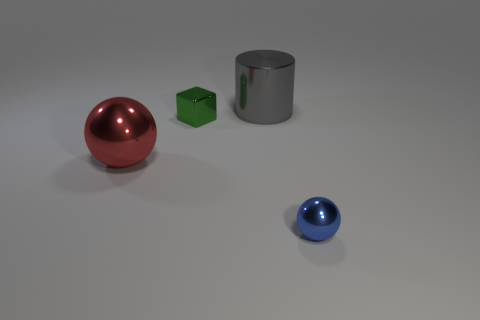There is a thing that is in front of the sphere on the left side of the tiny metal sphere; is there a large metal sphere left of it?
Offer a terse response. Yes. What shape is the small green thing that is the same material as the cylinder?
Ensure brevity in your answer.  Cube. Are there more big red metallic things than small brown blocks?
Provide a short and direct response. Yes. There is a small blue object; is it the same shape as the large object that is in front of the cylinder?
Keep it short and to the point. Yes. What color is the tiny thing behind the metallic object that is on the right side of the large metallic thing that is behind the red metal sphere?
Offer a terse response. Green. How many blue spheres have the same size as the gray metallic thing?
Offer a very short reply. 0. What number of big red matte objects are there?
Give a very brief answer. 0. Is the material of the red thing the same as the object that is right of the big gray metallic thing?
Your answer should be compact. Yes. What number of cyan objects are either big cylinders or tiny matte objects?
Provide a succinct answer. 0. What is the size of the green thing that is made of the same material as the big red sphere?
Offer a very short reply. Small. 